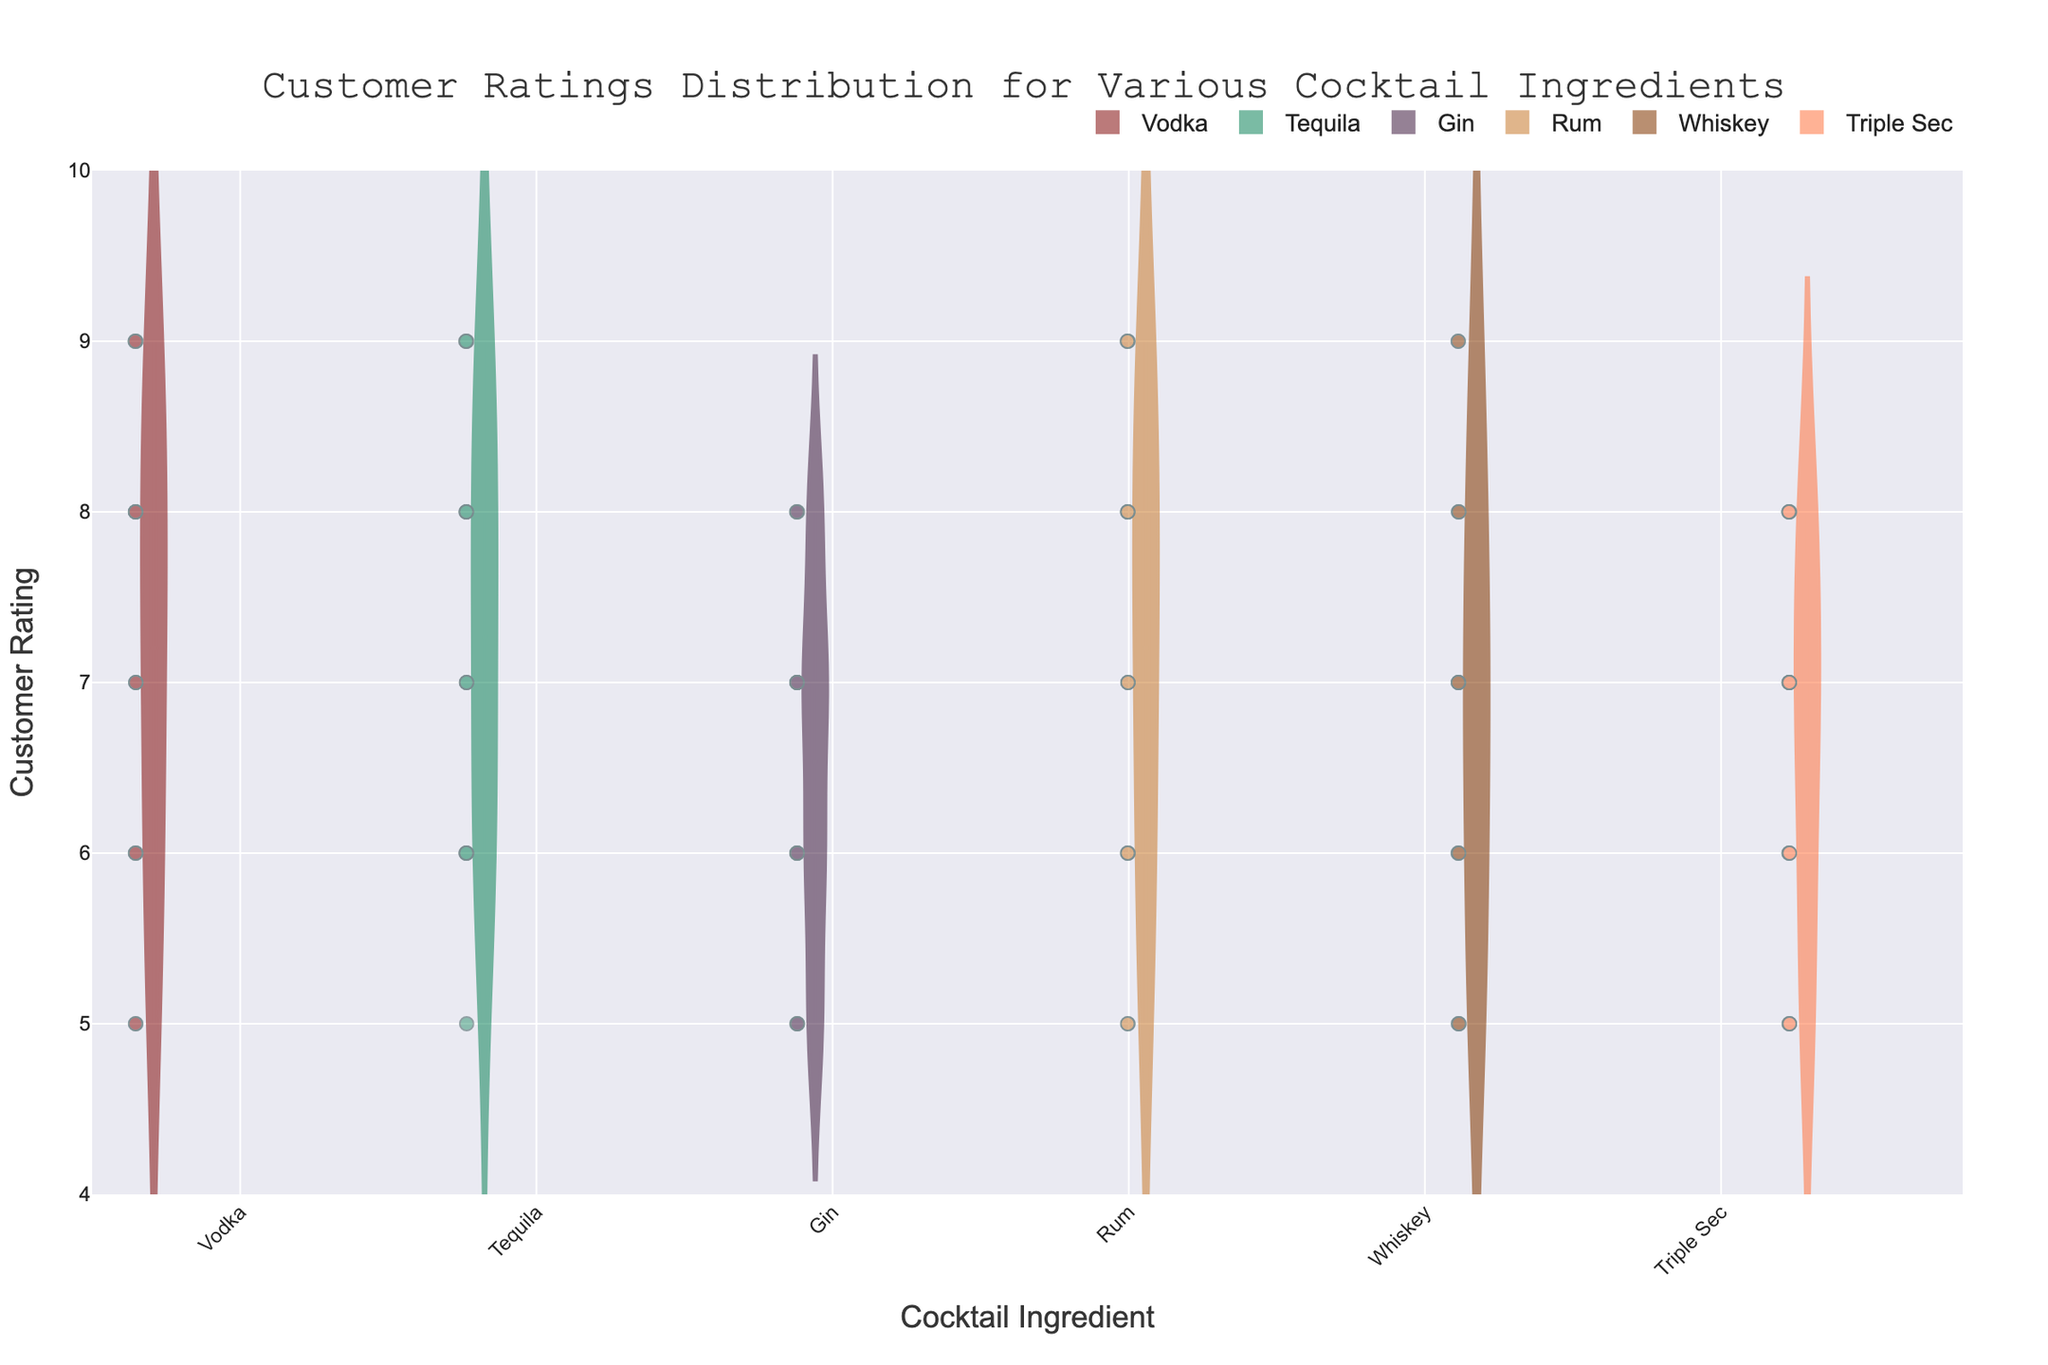What is the title of the plot? The title is usually found at the top of the plot. By looking at the top-central area, one can read the given title that summarizes the chart.
Answer: Customer Ratings Distribution for Various Cocktail Ingredients Which ingredient has the widest rating distribution based on the violin plot? To determine this, observe the width of the violin plots. The wider the plot, the more spread out the ratings are for that ingredient.
Answer: Whiskey What is the range of customer ratings shown on the y-axis? By looking at the y-axis, we can see the numerical labels at both ends, which indicate the minimum and maximum values.
Answer: 4 to 10 Which ingredient has the highest median rating, and what is that rating? The median rating is represented by a line inside the box plot within each violin plot. Compare these lines across ingredients to find the highest one.
Answer: Tequila, 7.5 Which ingredient has the lowest median rating, and what is that rating? Similar to finding the highest median, look for the median line that is lowest among all ingredients.
Answer: Gin, 6.5 How many ingredients have a visible box plot in their violin plot? Count the distinct box plots within the violin plots. Each ingredient has its box plot, so count the number of ingredients shown.
Answer: 6 Among Vodka and Triple Sec, which has more data points plotted? Observe the number of individual data points (small dots) within the violin plot areas for each ingredient to determine which one has more.
Answer: Vodka What is the mean rating for Rum based on the mean line in the box plot overlay? The mean rating is typically represented by another line or marker in the box plot. Check the mean line value inside Rum's box plot.
Answer: 7 What is the interquartile range (IQR) for Whiskey’s ratings? The IQR is the difference between the upper quartile (75th percentile) and lower quartile (25th percentile), visible within the box of the box plot. Calculate this difference for Whiskey.
Answer: 7 - 6 = 1 Between Gin and Rum, which ingredient has a higher overall rating spread? Compare the widths of the violin plots for Gin and Rum. The one with a broader spread has a higher range of ratings.
Answer: Rum 